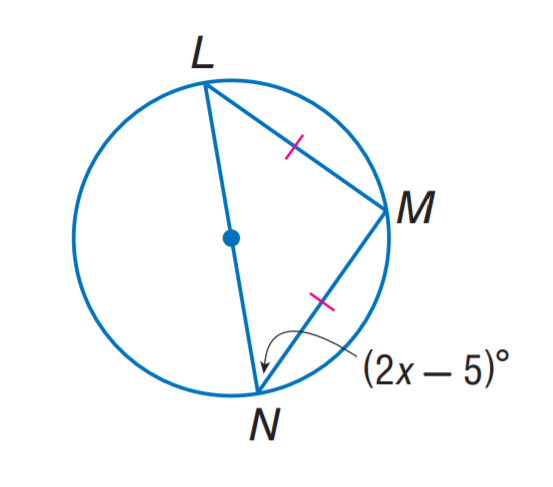Answer the mathemtical geometry problem and directly provide the correct option letter.
Question: Find x.
Choices: A: 25 B: 30 C: 35 D: 45 A 